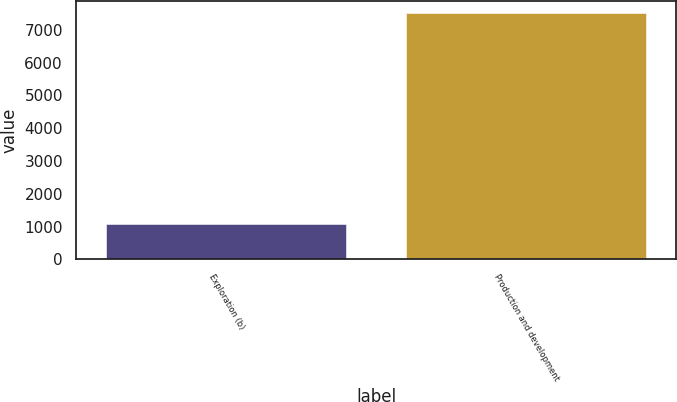Convert chart. <chart><loc_0><loc_0><loc_500><loc_500><bar_chart><fcel>Exploration (b)<fcel>Production and development<nl><fcel>1089<fcel>7505<nl></chart> 